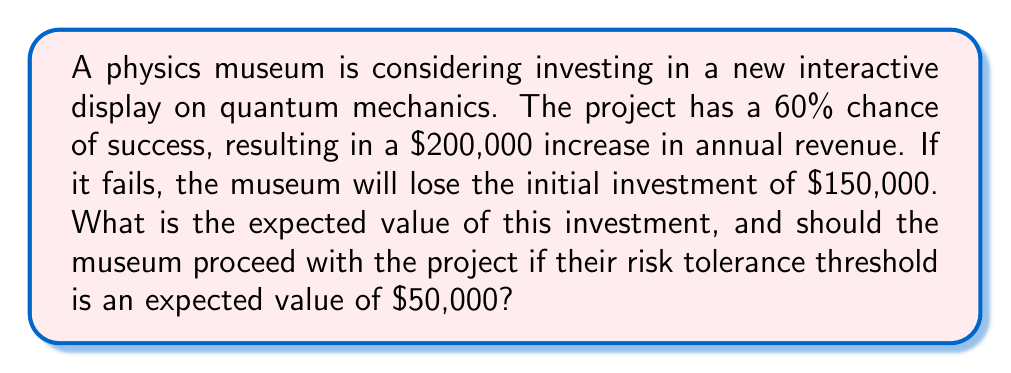Show me your answer to this math problem. To solve this problem, we need to calculate the expected value of the investment using the given probabilities and potential outcomes. Let's break it down step-by-step:

1. Define the probabilities and outcomes:
   - Probability of success: $p_s = 0.60$
   - Probability of failure: $p_f = 1 - p_s = 0.40$
   - Revenue increase if successful: $R = \$200,000$
   - Initial investment (potential loss): $I = \$150,000$

2. Calculate the expected value (EV) using the formula:
   $$EV = (p_s \times R) - (p_f \times I)$$

3. Substitute the values:
   $$EV = (0.60 \times \$200,000) - (0.40 \times \$150,000)$$

4. Solve the equation:
   $$EV = \$120,000 - \$60,000 = \$60,000$$

5. Compare the result to the risk tolerance threshold:
   The expected value (\$60,000) is greater than the risk tolerance threshold (\$50,000).

Therefore, the expected value of the investment is \$60,000, which exceeds the museum's risk tolerance threshold of \$50,000. Based on this analysis, the museum should proceed with the project.
Answer: The expected value of the investment is \$60,000. Since this exceeds the risk tolerance threshold of \$50,000, the museum should proceed with the project. 